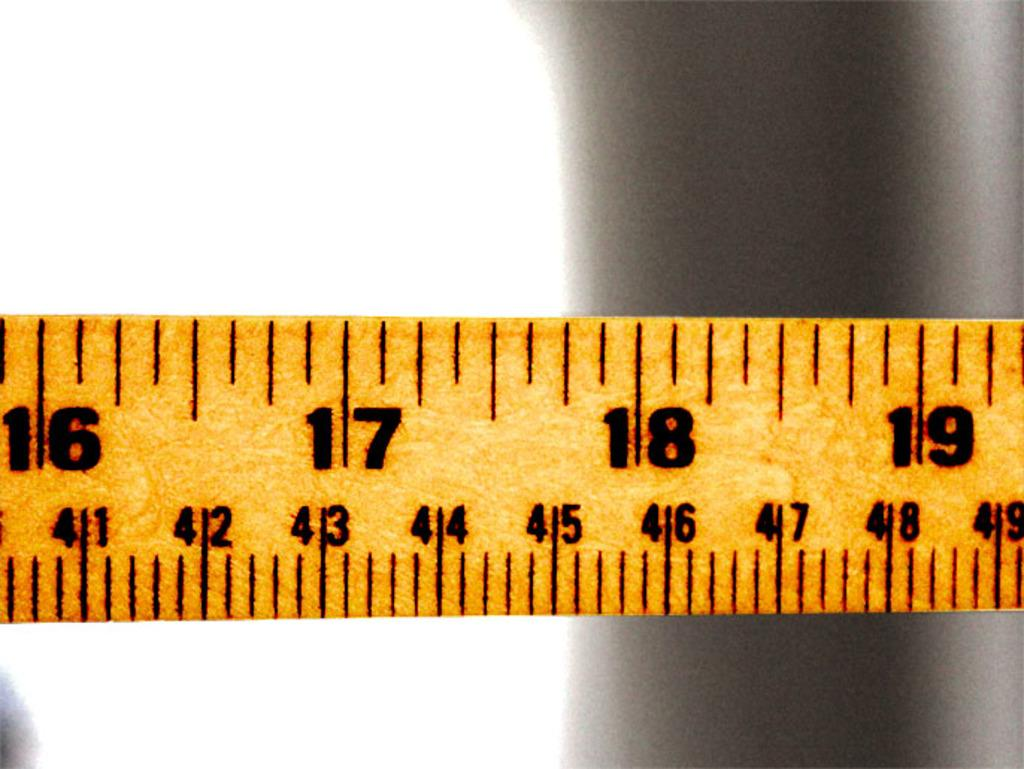Provide a one-sentence caption for the provided image. A yellow tape measure showing sixteen through nineteen. 